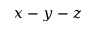<formula> <loc_0><loc_0><loc_500><loc_500>x - y - z</formula> 